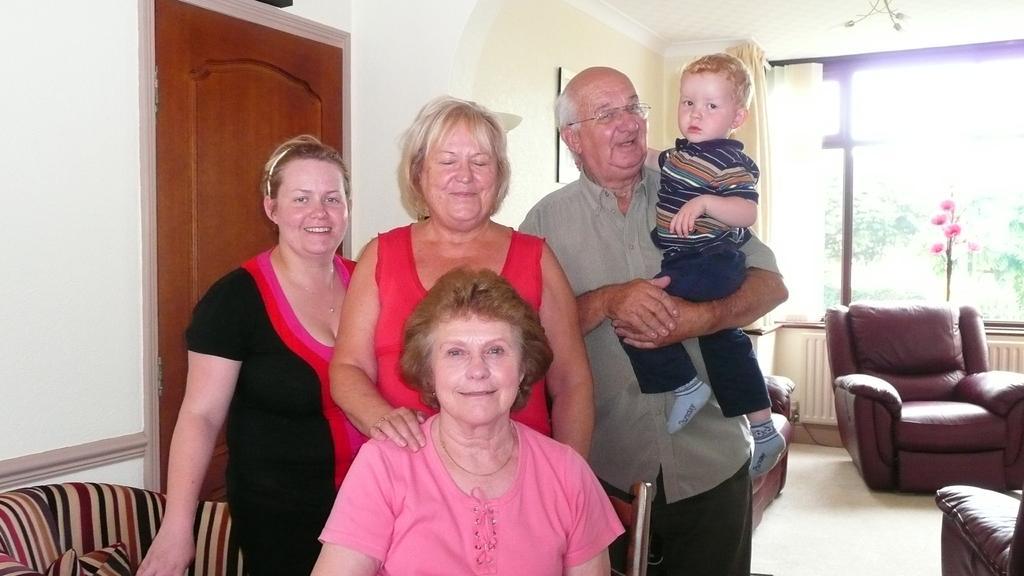Can you describe this image briefly? In this picture we can see some persons. This is floor and there are sofas. There is a door and this is wall. Here we can see a window and this is curtain. 